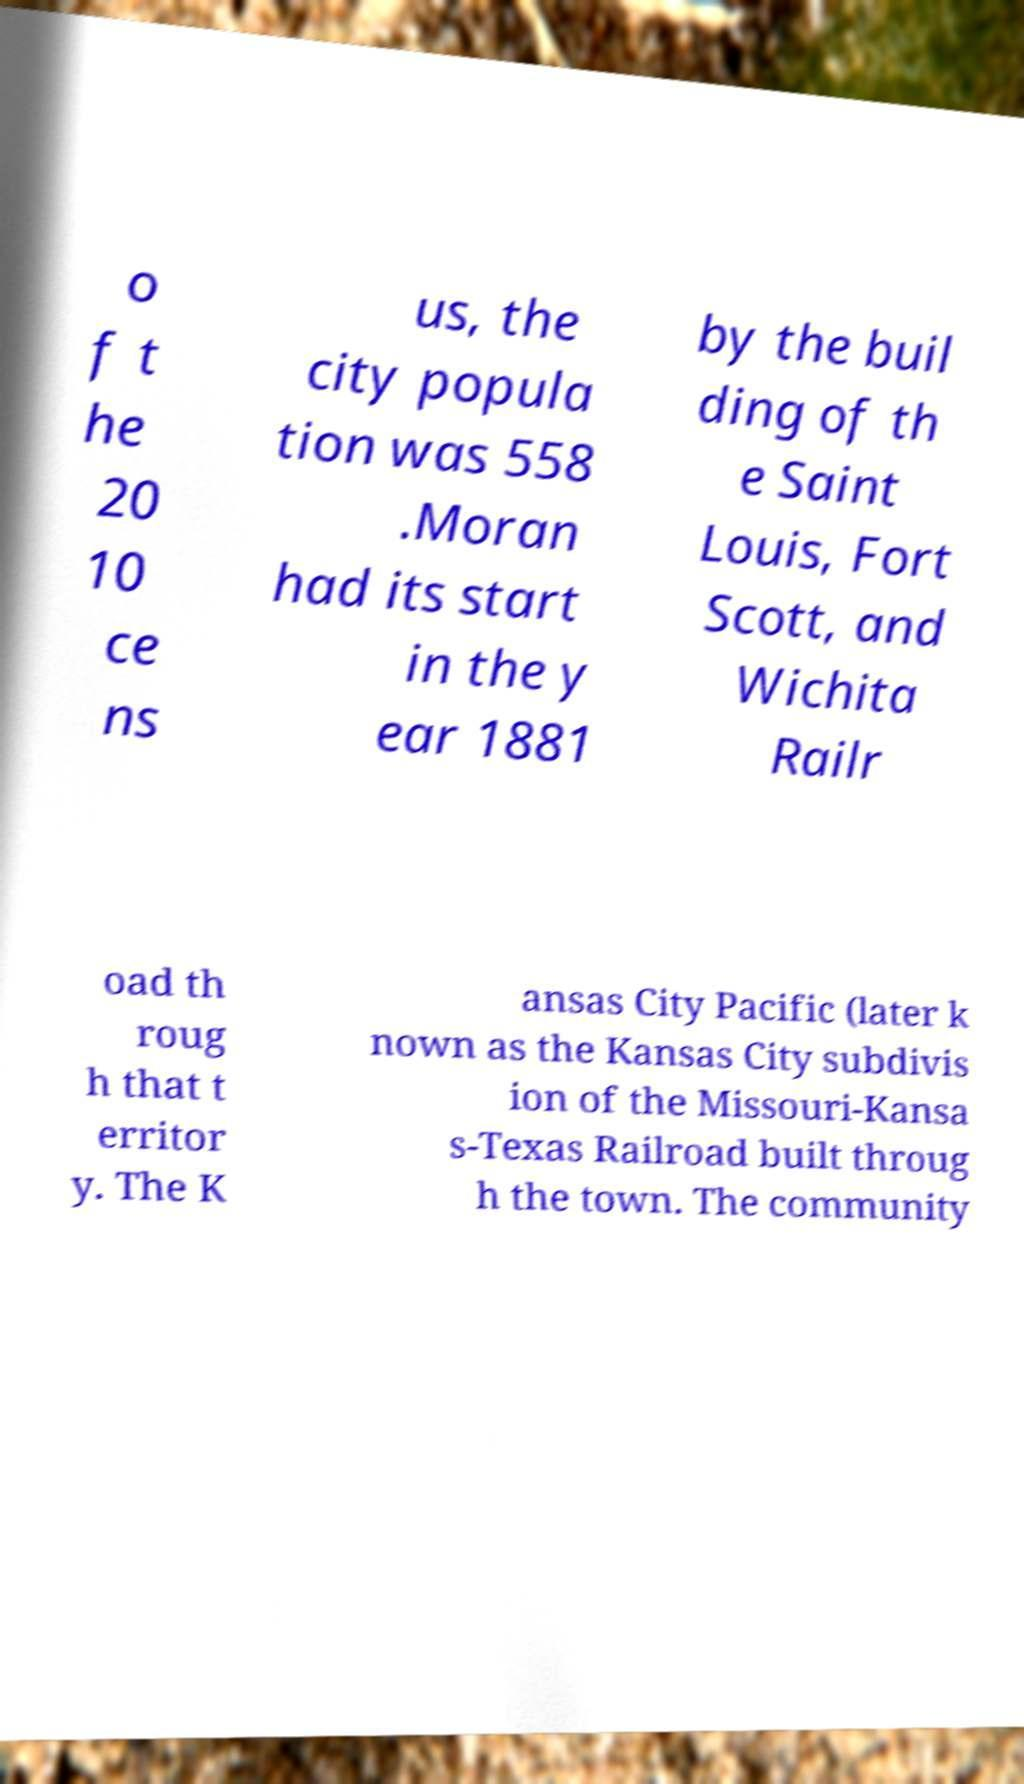There's text embedded in this image that I need extracted. Can you transcribe it verbatim? o f t he 20 10 ce ns us, the city popula tion was 558 .Moran had its start in the y ear 1881 by the buil ding of th e Saint Louis, Fort Scott, and Wichita Railr oad th roug h that t erritor y. The K ansas City Pacific (later k nown as the Kansas City subdivis ion of the Missouri-Kansa s-Texas Railroad built throug h the town. The community 